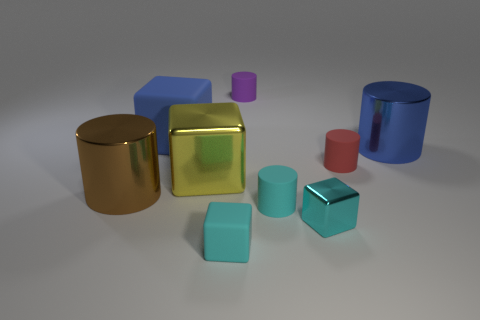What is the color of the big thing behind the blue object to the right of the large yellow shiny block?
Your answer should be compact. Blue. How many metallic objects are small cyan cylinders or blue blocks?
Offer a terse response. 0. Are the large yellow object and the big brown cylinder made of the same material?
Ensure brevity in your answer.  Yes. There is a large blue thing that is on the right side of the small matte cylinder that is in front of the brown shiny object; what is it made of?
Your response must be concise. Metal. What number of large objects are blocks or cyan cylinders?
Your answer should be very brief. 2. How big is the brown cylinder?
Provide a succinct answer. Large. Are there more big blue cubes that are behind the blue block than blue metallic things?
Keep it short and to the point. No. Are there an equal number of rubber objects to the left of the tiny red rubber object and tiny red objects that are in front of the small cyan cylinder?
Your answer should be compact. No. The object that is both in front of the big metal cube and behind the small cyan matte cylinder is what color?
Offer a terse response. Brown. Is there anything else that has the same size as the red cylinder?
Keep it short and to the point. Yes. 